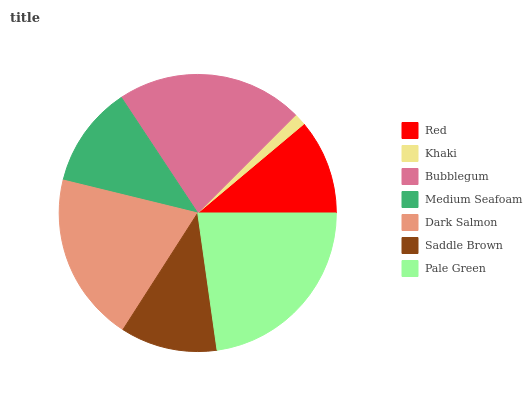Is Khaki the minimum?
Answer yes or no. Yes. Is Pale Green the maximum?
Answer yes or no. Yes. Is Bubblegum the minimum?
Answer yes or no. No. Is Bubblegum the maximum?
Answer yes or no. No. Is Bubblegum greater than Khaki?
Answer yes or no. Yes. Is Khaki less than Bubblegum?
Answer yes or no. Yes. Is Khaki greater than Bubblegum?
Answer yes or no. No. Is Bubblegum less than Khaki?
Answer yes or no. No. Is Medium Seafoam the high median?
Answer yes or no. Yes. Is Medium Seafoam the low median?
Answer yes or no. Yes. Is Khaki the high median?
Answer yes or no. No. Is Bubblegum the low median?
Answer yes or no. No. 